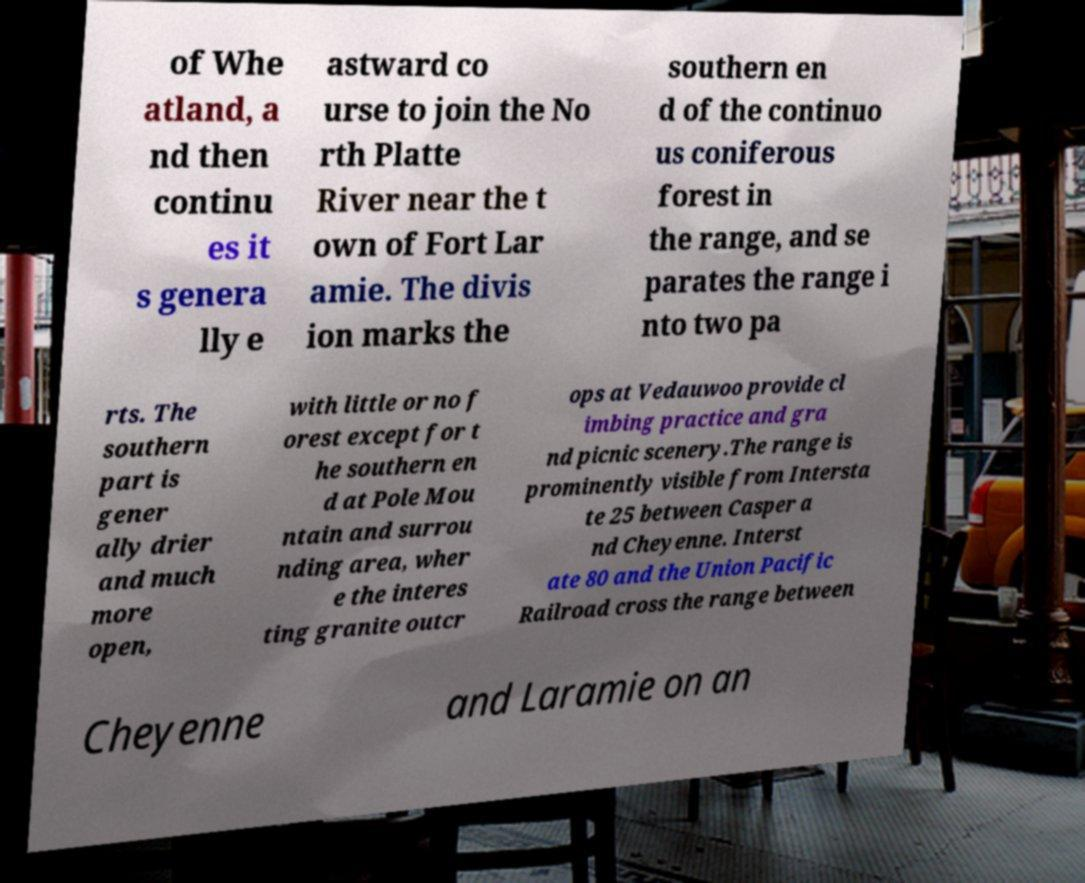What messages or text are displayed in this image? I need them in a readable, typed format. of Whe atland, a nd then continu es it s genera lly e astward co urse to join the No rth Platte River near the t own of Fort Lar amie. The divis ion marks the southern en d of the continuo us coniferous forest in the range, and se parates the range i nto two pa rts. The southern part is gener ally drier and much more open, with little or no f orest except for t he southern en d at Pole Mou ntain and surrou nding area, wher e the interes ting granite outcr ops at Vedauwoo provide cl imbing practice and gra nd picnic scenery.The range is prominently visible from Intersta te 25 between Casper a nd Cheyenne. Interst ate 80 and the Union Pacific Railroad cross the range between Cheyenne and Laramie on an 